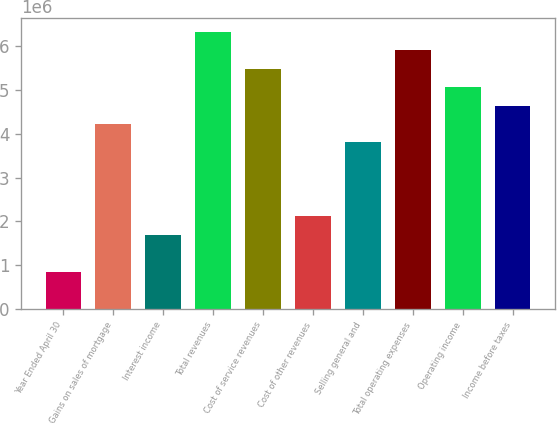Convert chart to OTSL. <chart><loc_0><loc_0><loc_500><loc_500><bar_chart><fcel>Year Ended April 30<fcel>Gains on sales of mortgage<fcel>Interest income<fcel>Total revenues<fcel>Cost of service revenues<fcel>Cost of other revenues<fcel>Selling general and<fcel>Total operating expenses<fcel>Operating income<fcel>Income before taxes<nl><fcel>844971<fcel>4.22485e+06<fcel>1.68994e+06<fcel>6.33727e+06<fcel>5.4923e+06<fcel>2.11242e+06<fcel>3.80236e+06<fcel>5.91478e+06<fcel>5.06981e+06<fcel>4.64733e+06<nl></chart> 